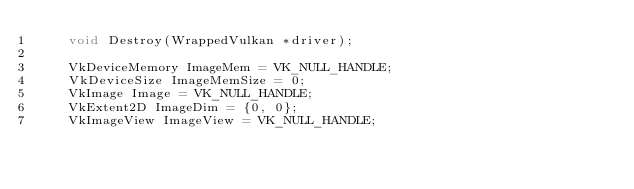<code> <loc_0><loc_0><loc_500><loc_500><_C_>    void Destroy(WrappedVulkan *driver);

    VkDeviceMemory ImageMem = VK_NULL_HANDLE;
    VkDeviceSize ImageMemSize = 0;
    VkImage Image = VK_NULL_HANDLE;
    VkExtent2D ImageDim = {0, 0};
    VkImageView ImageView = VK_NULL_HANDLE;</code> 